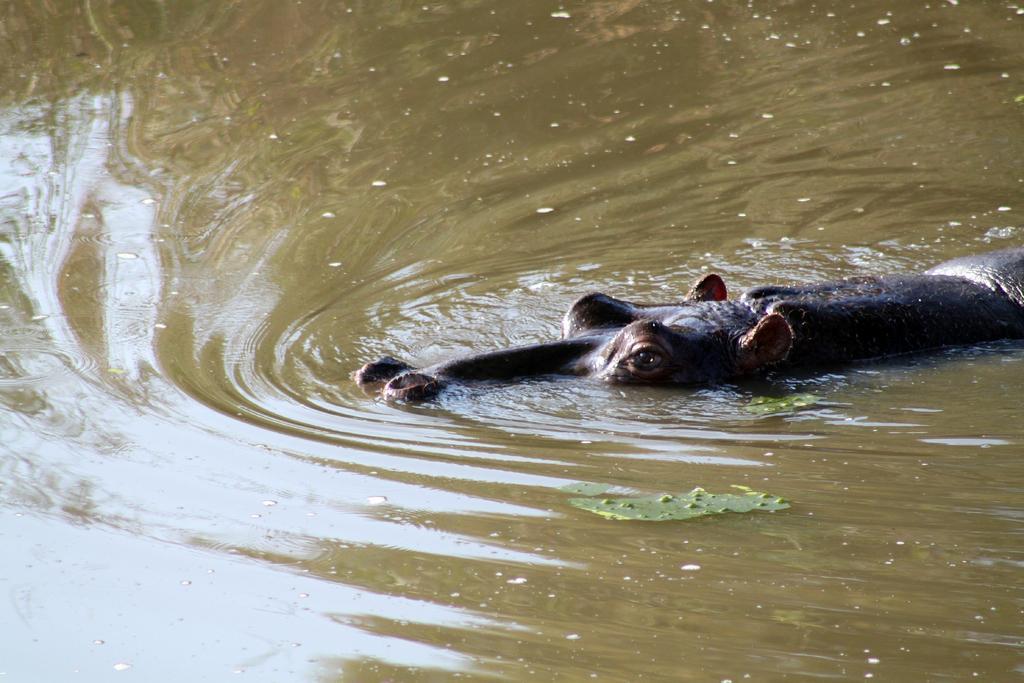How would you summarize this image in a sentence or two? In this image I can see an animal in the water and the animal is in brown color and I can also see few leaves in green color. 